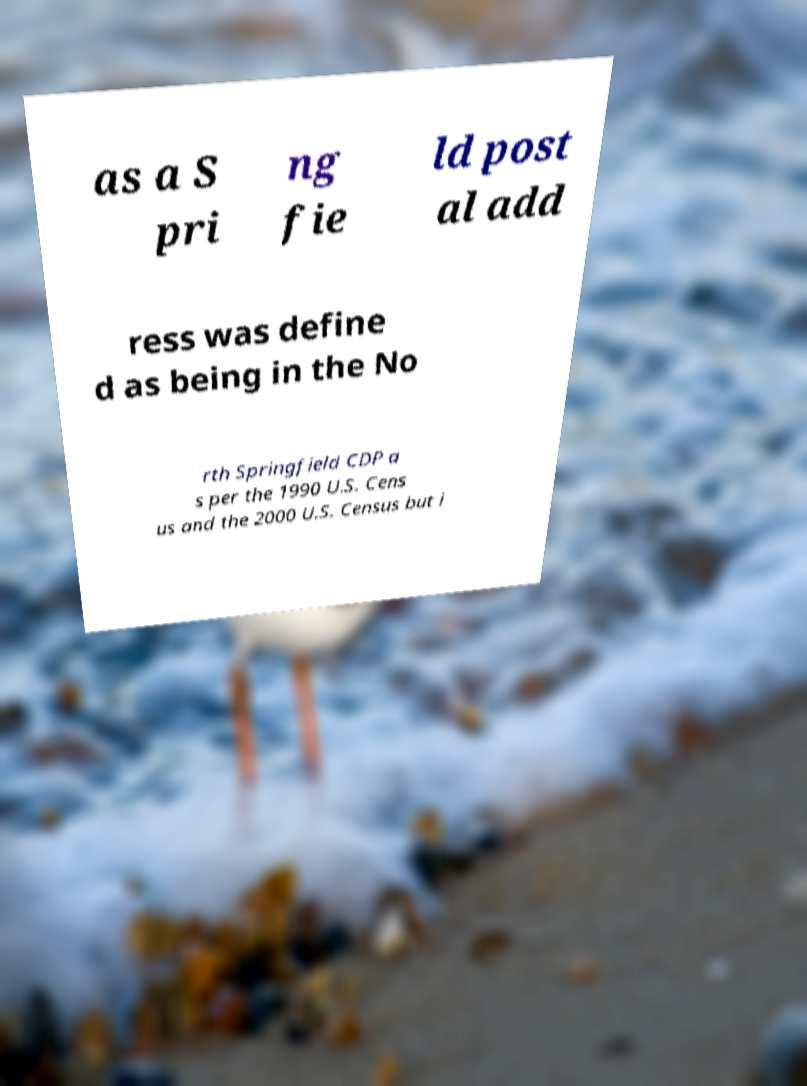Can you accurately transcribe the text from the provided image for me? as a S pri ng fie ld post al add ress was define d as being in the No rth Springfield CDP a s per the 1990 U.S. Cens us and the 2000 U.S. Census but i 